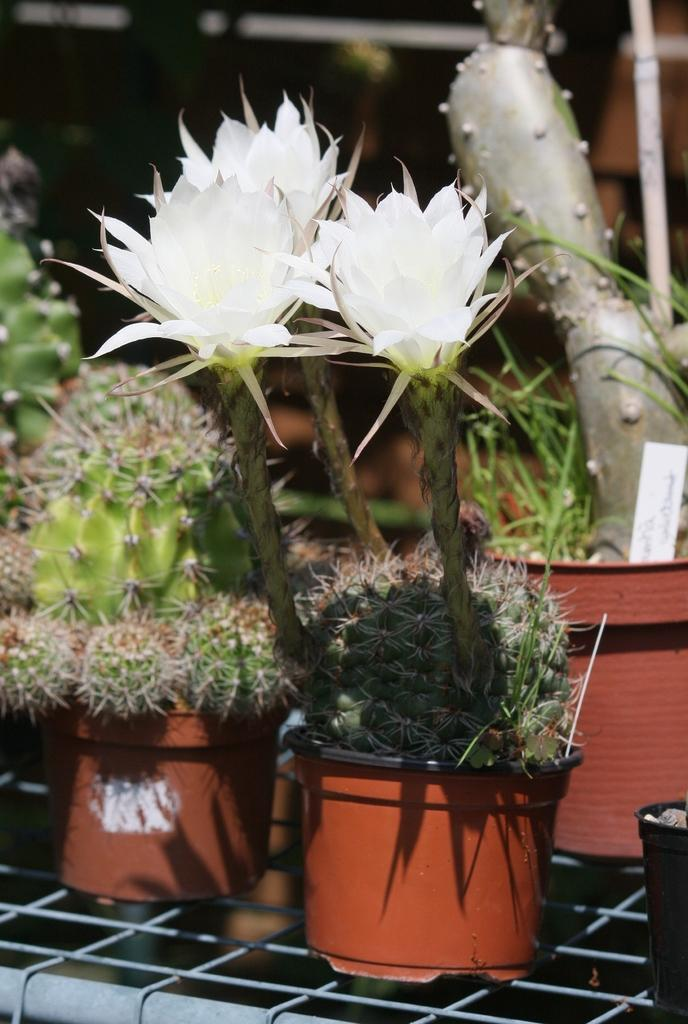What type of plants are in the image? There are cactus plants in the image. What color are the flowers in the image? There are white flowers in the image. What are the plants contained in? There are pots on the surface in the image. What type of quilt can be seen covering the plants in the image? There is no quilt present in the image; the plants are in pots. Is there a source of water visible in the image? There is no water source visible in the image. 